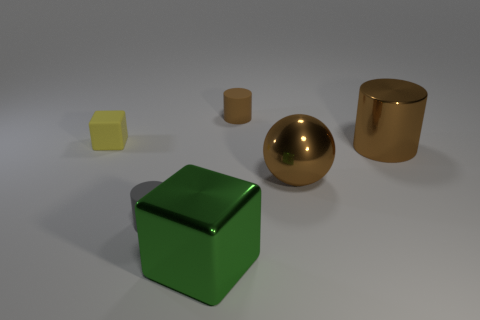Is there a cylinder that has the same size as the green cube?
Make the answer very short. Yes. How big is the green object?
Offer a terse response. Large. Is the number of spheres that are to the left of the big block the same as the number of small yellow objects?
Your response must be concise. No. What number of other things are the same color as the big cylinder?
Make the answer very short. 2. There is a cylinder that is to the left of the big brown sphere and behind the gray rubber thing; what color is it?
Offer a very short reply. Brown. There is a block behind the small rubber cylinder that is left of the big object that is in front of the metal sphere; how big is it?
Give a very brief answer. Small. What number of objects are either brown objects in front of the small brown rubber thing or things behind the tiny yellow rubber cube?
Give a very brief answer. 3. The large green object has what shape?
Offer a terse response. Cube. What number of other things are there of the same material as the tiny brown object
Keep it short and to the point. 2. The yellow rubber object that is the same shape as the green thing is what size?
Ensure brevity in your answer.  Small. 